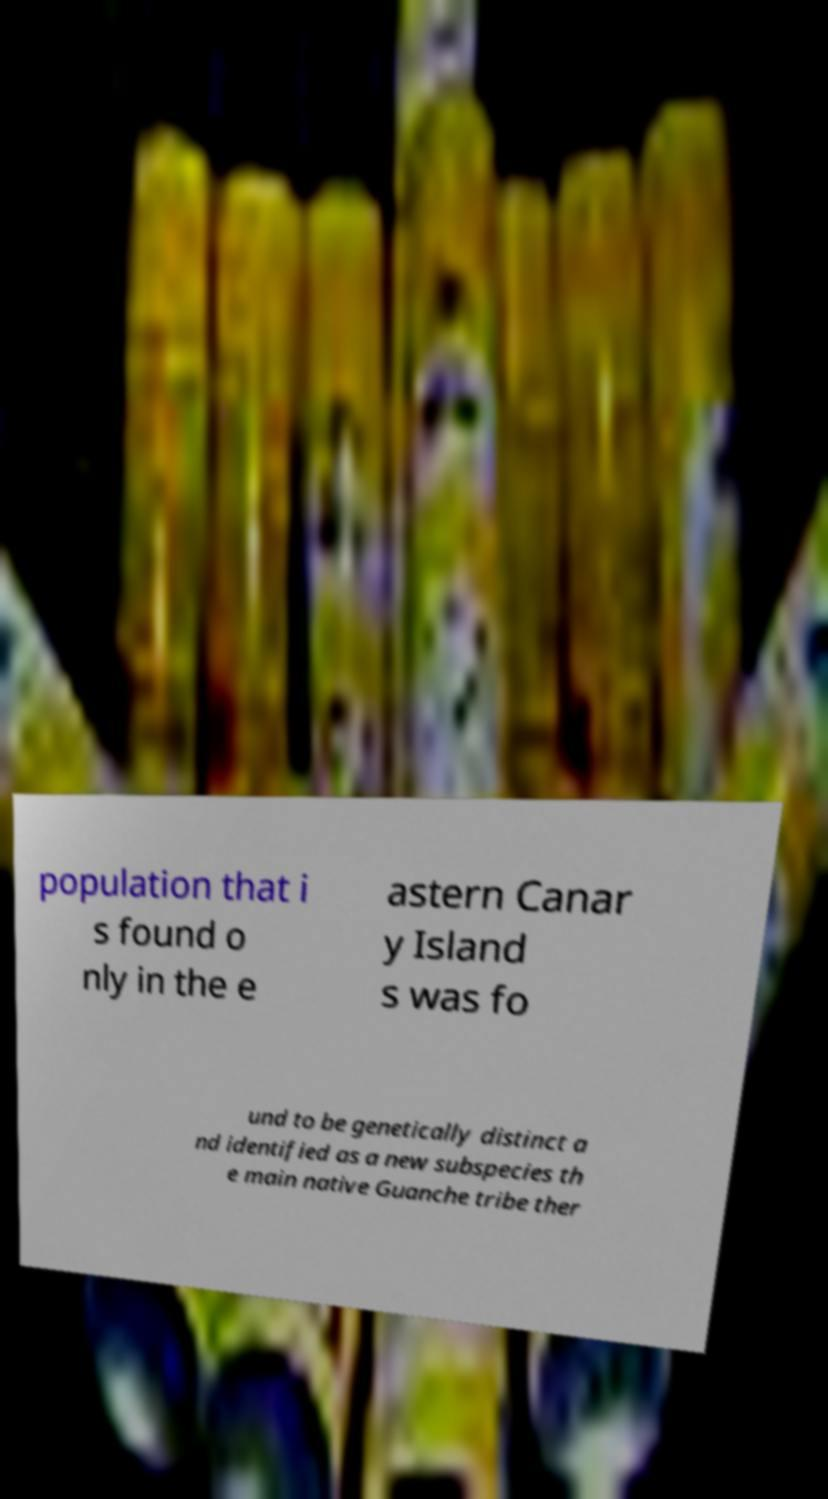Please identify and transcribe the text found in this image. population that i s found o nly in the e astern Canar y Island s was fo und to be genetically distinct a nd identified as a new subspecies th e main native Guanche tribe ther 